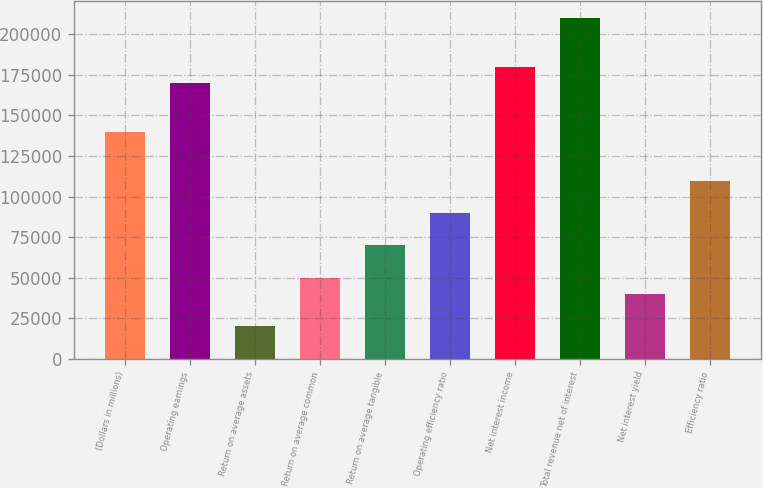Convert chart. <chart><loc_0><loc_0><loc_500><loc_500><bar_chart><fcel>(Dollars in millions)<fcel>Operating earnings<fcel>Return on average assets<fcel>Return on average common<fcel>Return on average tangible<fcel>Operating efficiency ratio<fcel>Net interest income<fcel>Total revenue net of interest<fcel>Net interest yield<fcel>Efficiency ratio<nl><fcel>139805<fcel>169764<fcel>19972.2<fcel>49930.5<fcel>69902.7<fcel>89874.9<fcel>179750<fcel>209708<fcel>39944.4<fcel>109847<nl></chart> 